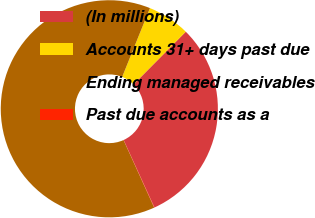Convert chart. <chart><loc_0><loc_0><loc_500><loc_500><pie_chart><fcel>(In millions)<fcel>Accounts 31+ days past due<fcel>Ending managed receivables<fcel>Past due accounts as a<nl><fcel>30.73%<fcel>6.33%<fcel>62.88%<fcel>0.05%<nl></chart> 